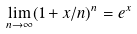<formula> <loc_0><loc_0><loc_500><loc_500>\lim _ { n \to \infty } ( 1 + x / n ) ^ { n } = e ^ { x }</formula> 